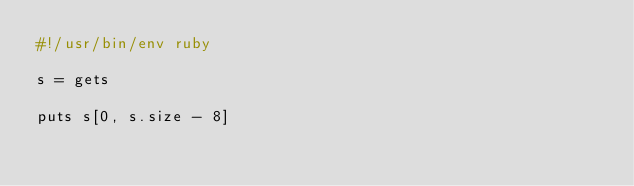<code> <loc_0><loc_0><loc_500><loc_500><_Ruby_>#!/usr/bin/env ruby

s = gets

puts s[0, s.size - 8]
</code> 